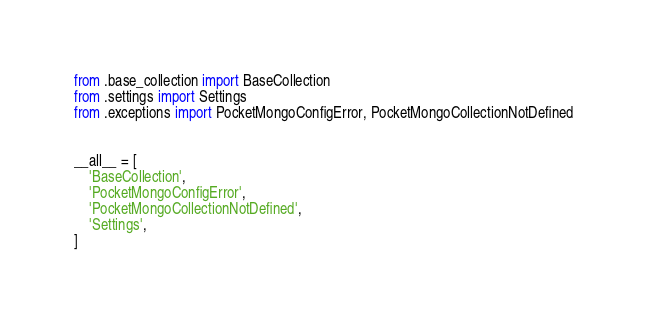<code> <loc_0><loc_0><loc_500><loc_500><_Python_>from .base_collection import BaseCollection
from .settings import Settings
from .exceptions import PocketMongoConfigError, PocketMongoCollectionNotDefined


__all__ = [
    'BaseCollection',
    'PocketMongoConfigError',
    'PocketMongoCollectionNotDefined',
    'Settings',
]
</code> 